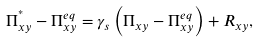Convert formula to latex. <formula><loc_0><loc_0><loc_500><loc_500>\Pi _ { x y } ^ { ^ { * } } - \Pi _ { x y } ^ { e q } = \gamma _ { s } \left ( \Pi _ { x y } - \Pi _ { x y } ^ { e q } \right ) + R _ { x y } ,</formula> 